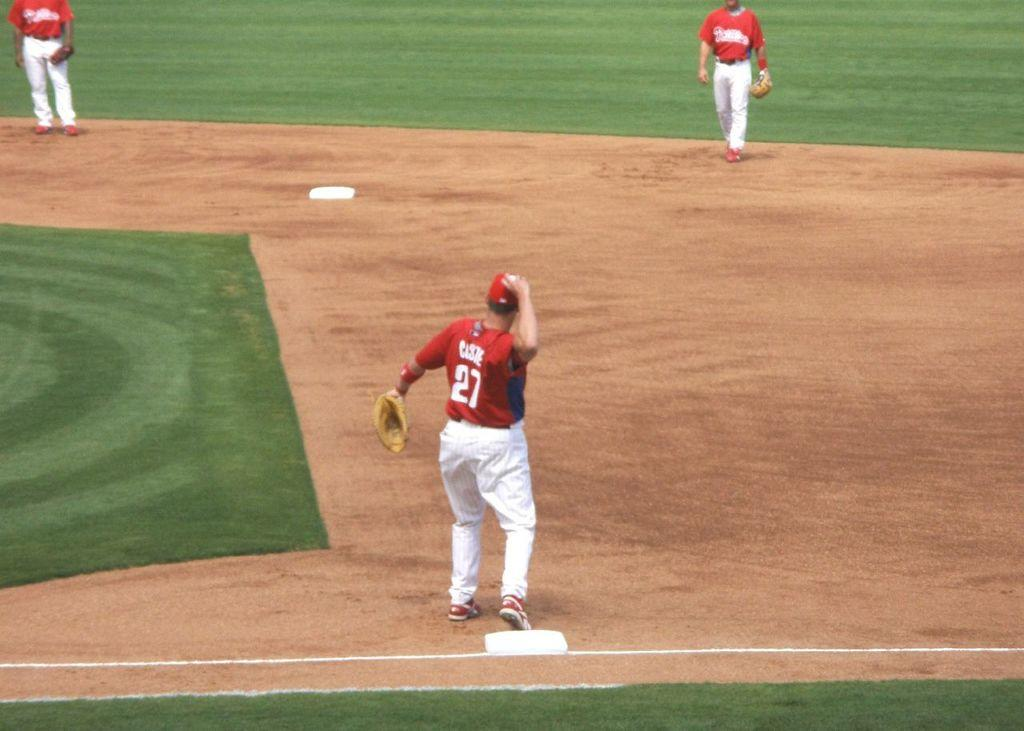<image>
Summarize the visual content of the image. First base player wearing a red number 27 jersey is about to throw a ball. 